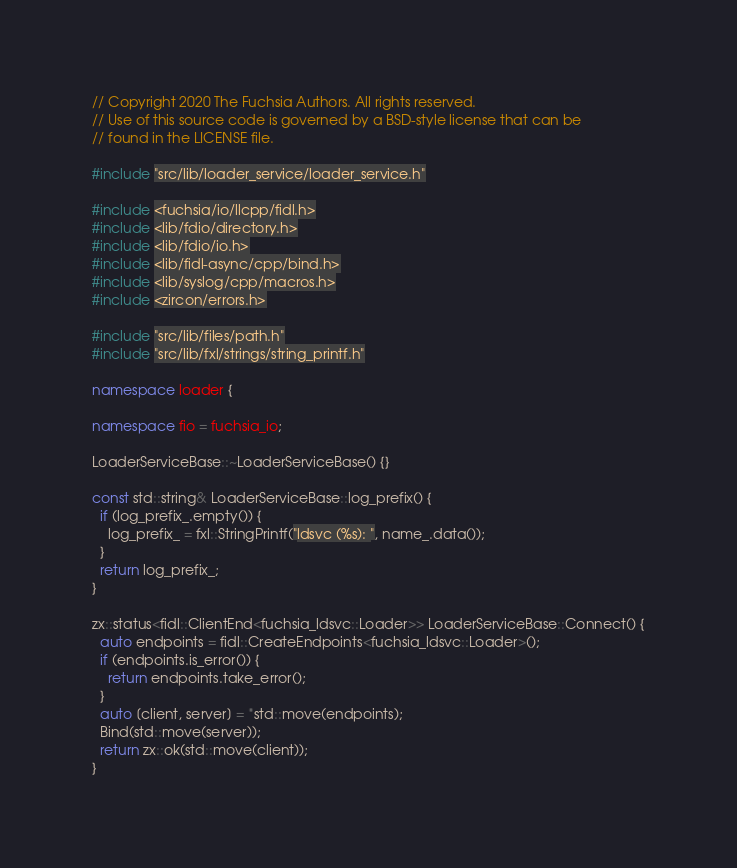Convert code to text. <code><loc_0><loc_0><loc_500><loc_500><_C++_>// Copyright 2020 The Fuchsia Authors. All rights reserved.
// Use of this source code is governed by a BSD-style license that can be
// found in the LICENSE file.

#include "src/lib/loader_service/loader_service.h"

#include <fuchsia/io/llcpp/fidl.h>
#include <lib/fdio/directory.h>
#include <lib/fdio/io.h>
#include <lib/fidl-async/cpp/bind.h>
#include <lib/syslog/cpp/macros.h>
#include <zircon/errors.h>

#include "src/lib/files/path.h"
#include "src/lib/fxl/strings/string_printf.h"

namespace loader {

namespace fio = fuchsia_io;

LoaderServiceBase::~LoaderServiceBase() {}

const std::string& LoaderServiceBase::log_prefix() {
  if (log_prefix_.empty()) {
    log_prefix_ = fxl::StringPrintf("ldsvc (%s): ", name_.data());
  }
  return log_prefix_;
}

zx::status<fidl::ClientEnd<fuchsia_ldsvc::Loader>> LoaderServiceBase::Connect() {
  auto endpoints = fidl::CreateEndpoints<fuchsia_ldsvc::Loader>();
  if (endpoints.is_error()) {
    return endpoints.take_error();
  }
  auto [client, server] = *std::move(endpoints);
  Bind(std::move(server));
  return zx::ok(std::move(client));
}
</code> 